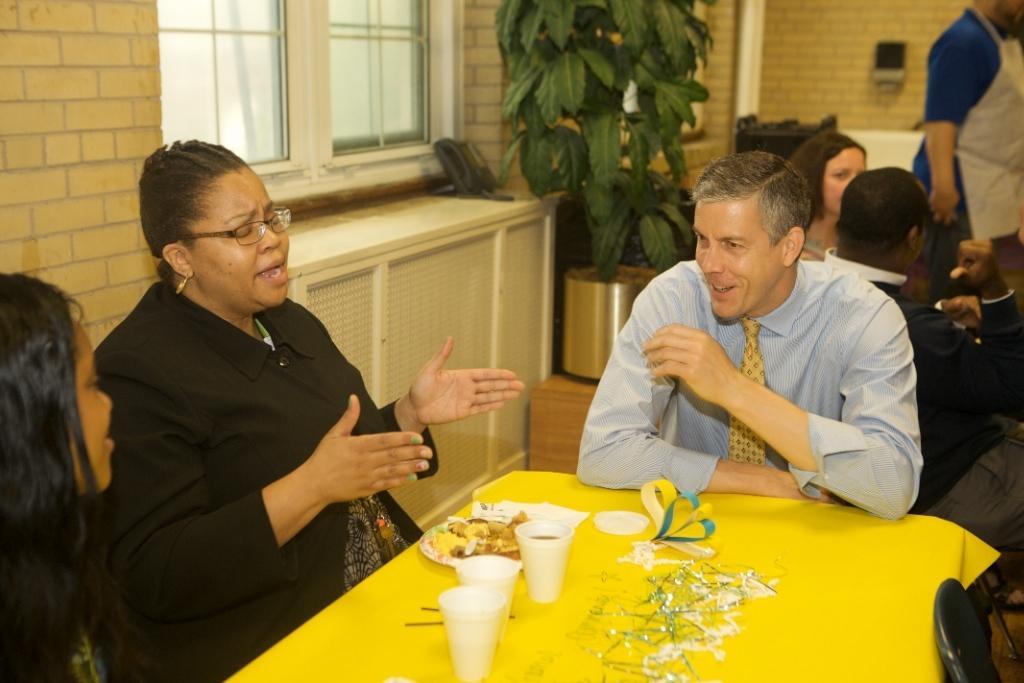How would you summarize this image in a sentence or two? In the image there are two women and man sat around the table,there are coffee cups and food on the table and on back side there are few people say and in the middle there is a plant and on left side wall there is window. 